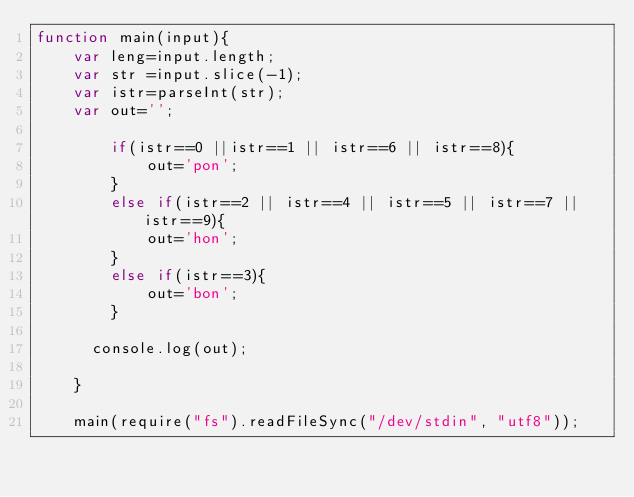Convert code to text. <code><loc_0><loc_0><loc_500><loc_500><_JavaScript_>function main(input){
    var leng=input.length;
    var str =input.slice(-1);
    var istr=parseInt(str);
    var out='';
    
        if(istr==0 ||istr==1 || istr==6 || istr==8){
            out='pon';
        }
        else if(istr==2 || istr==4 || istr==5 || istr==7 || istr==9){
            out='hon';
        }
        else if(istr==3){
            out='bon';
        }
      
      console.log(out);
     
    }
     
    main(require("fs").readFileSync("/dev/stdin", "utf8"));</code> 